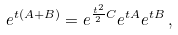<formula> <loc_0><loc_0><loc_500><loc_500>e ^ { t ( A + B ) } = e ^ { \frac { t ^ { 2 } } { 2 } C } e ^ { t A } e ^ { t B } \, ,</formula> 